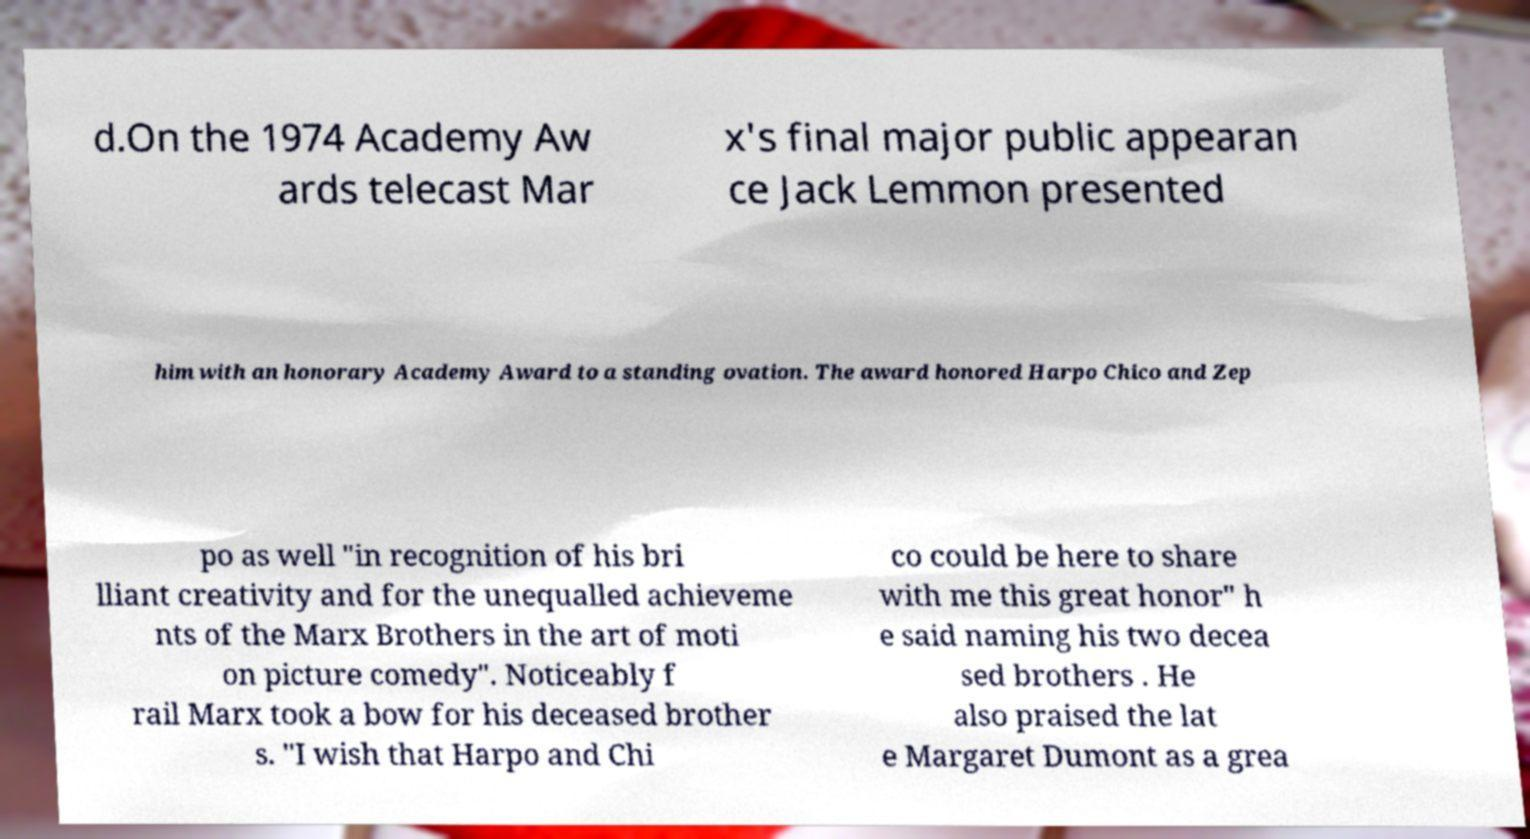For documentation purposes, I need the text within this image transcribed. Could you provide that? d.On the 1974 Academy Aw ards telecast Mar x's final major public appearan ce Jack Lemmon presented him with an honorary Academy Award to a standing ovation. The award honored Harpo Chico and Zep po as well "in recognition of his bri lliant creativity and for the unequalled achieveme nts of the Marx Brothers in the art of moti on picture comedy". Noticeably f rail Marx took a bow for his deceased brother s. "I wish that Harpo and Chi co could be here to share with me this great honor" h e said naming his two decea sed brothers . He also praised the lat e Margaret Dumont as a grea 